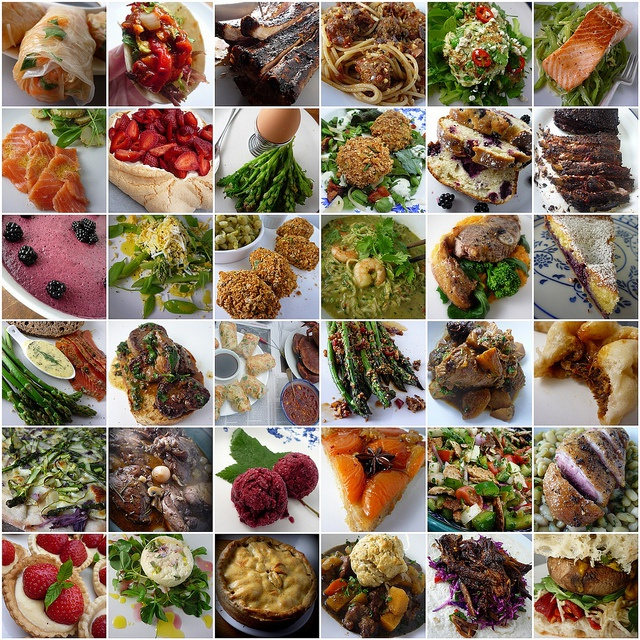Describe the objects in this image and their specific colors. I can see pizza in white, black, darkgray, darkgreen, and olive tones, sandwich in white, tan, maroon, and black tones, sandwich in white, olive, black, and lightgray tones, sandwich in white, black, maroon, beige, and olive tones, and cake in white, brown, black, maroon, and salmon tones in this image. 